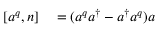Convert formula to latex. <formula><loc_0><loc_0><loc_500><loc_500>\begin{array} { r l } { [ a ^ { q } , n ] } & = ( a ^ { q } a ^ { \dagger } - a ^ { \dagger } a ^ { q } ) a } \end{array}</formula> 